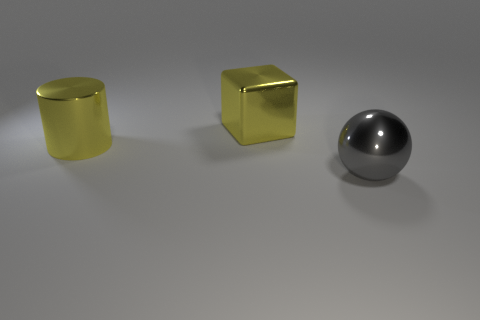Does the large yellow object on the right side of the yellow cylinder have the same material as the large thing that is on the left side of the block?
Your answer should be compact. Yes. There is a shiny object that is on the right side of the block; what shape is it?
Ensure brevity in your answer.  Sphere. How many objects are either big cylinders or things that are on the left side of the metallic ball?
Your answer should be very brief. 2. Is the big block made of the same material as the yellow cylinder?
Offer a terse response. Yes. Are there an equal number of big things left of the big shiny ball and yellow cubes on the left side of the yellow cylinder?
Ensure brevity in your answer.  No. There is a large gray metallic object; how many things are in front of it?
Give a very brief answer. 0. How many objects are either yellow cylinders or large cyan blocks?
Ensure brevity in your answer.  1. How many gray spheres have the same size as the metal cylinder?
Your response must be concise. 1. There is a shiny thing that is right of the yellow thing that is behind the big metallic cylinder; what shape is it?
Ensure brevity in your answer.  Sphere. Are there fewer shiny blocks than red rubber things?
Give a very brief answer. No. 